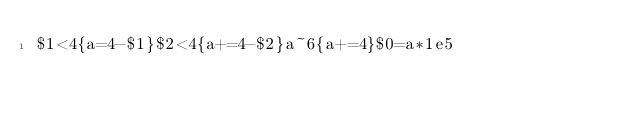Convert code to text. <code><loc_0><loc_0><loc_500><loc_500><_Awk_>$1<4{a=4-$1}$2<4{a+=4-$2}a~6{a+=4}$0=a*1e5</code> 